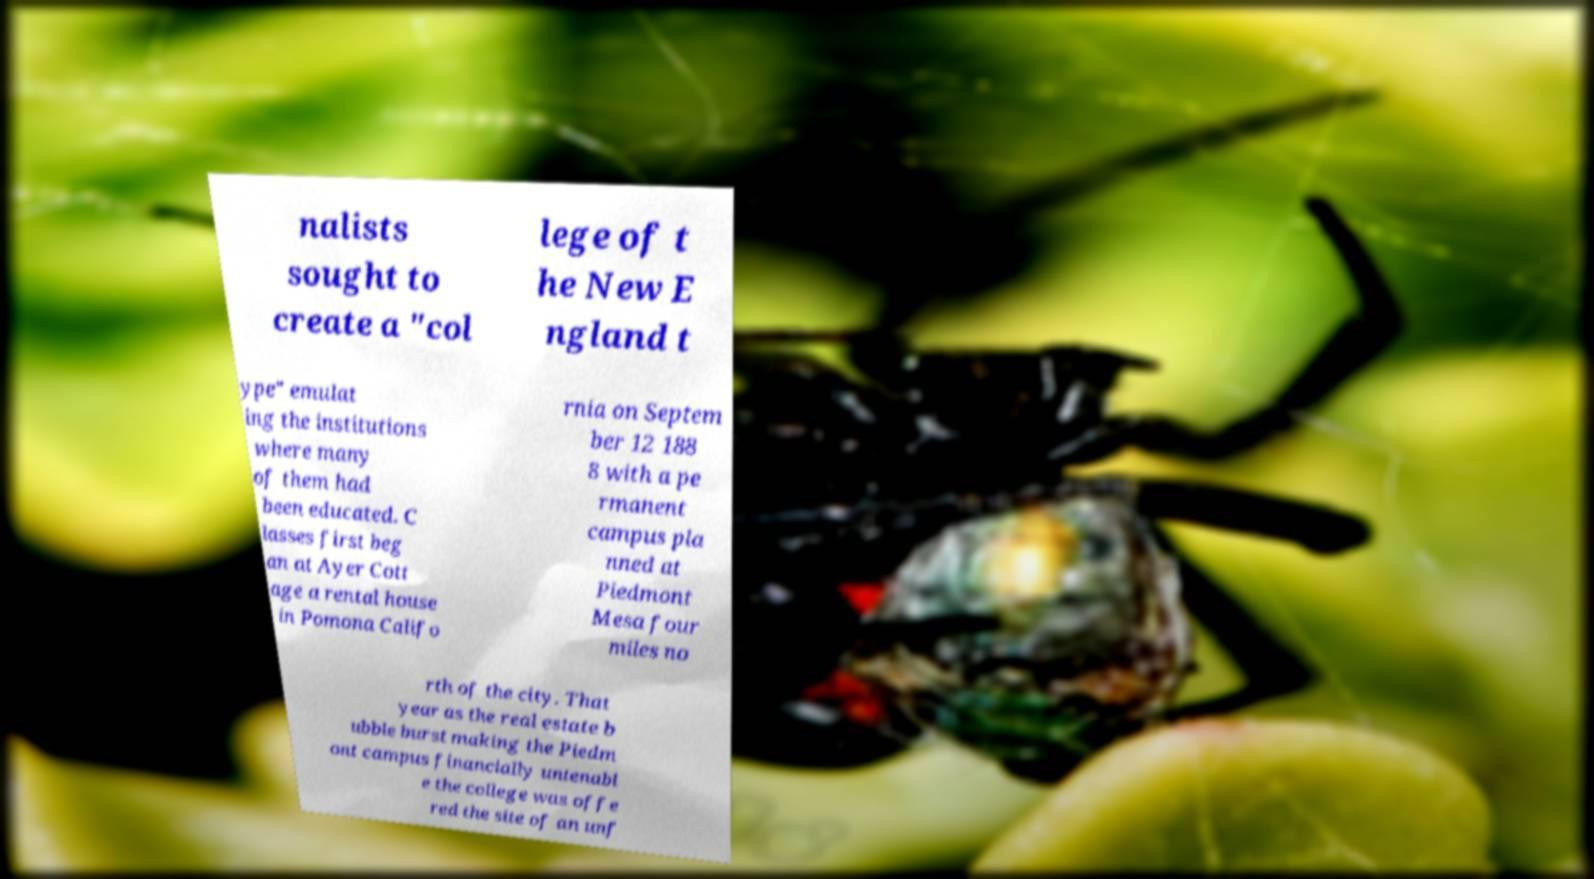There's text embedded in this image that I need extracted. Can you transcribe it verbatim? nalists sought to create a "col lege of t he New E ngland t ype" emulat ing the institutions where many of them had been educated. C lasses first beg an at Ayer Cott age a rental house in Pomona Califo rnia on Septem ber 12 188 8 with a pe rmanent campus pla nned at Piedmont Mesa four miles no rth of the city. That year as the real estate b ubble burst making the Piedm ont campus financially untenabl e the college was offe red the site of an unf 